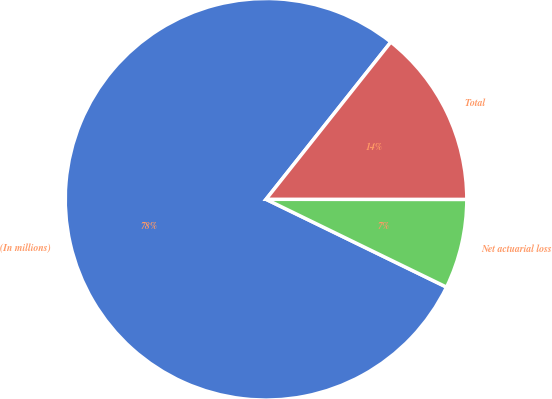<chart> <loc_0><loc_0><loc_500><loc_500><pie_chart><fcel>(In millions)<fcel>Net actuarial loss<fcel>Total<nl><fcel>78.47%<fcel>7.2%<fcel>14.33%<nl></chart> 